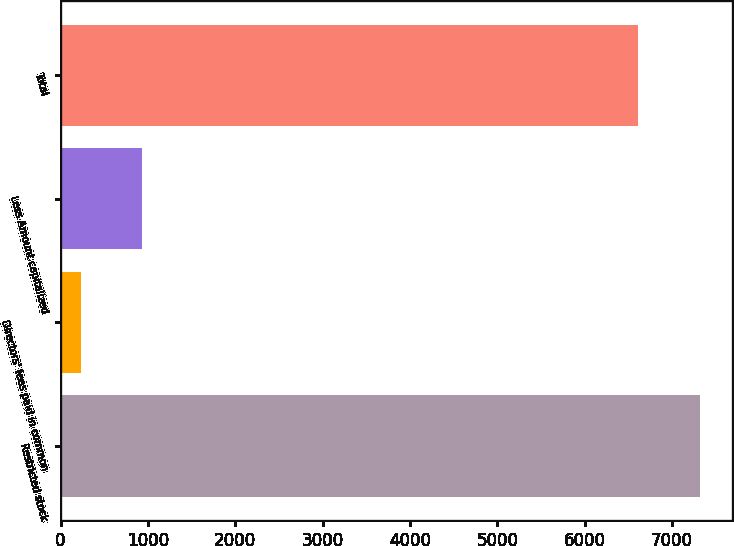Convert chart to OTSL. <chart><loc_0><loc_0><loc_500><loc_500><bar_chart><fcel>Restricted stock<fcel>Directors' fees paid in common<fcel>Less Amount capitalized<fcel>Total<nl><fcel>7315.5<fcel>231<fcel>931.5<fcel>6615<nl></chart> 